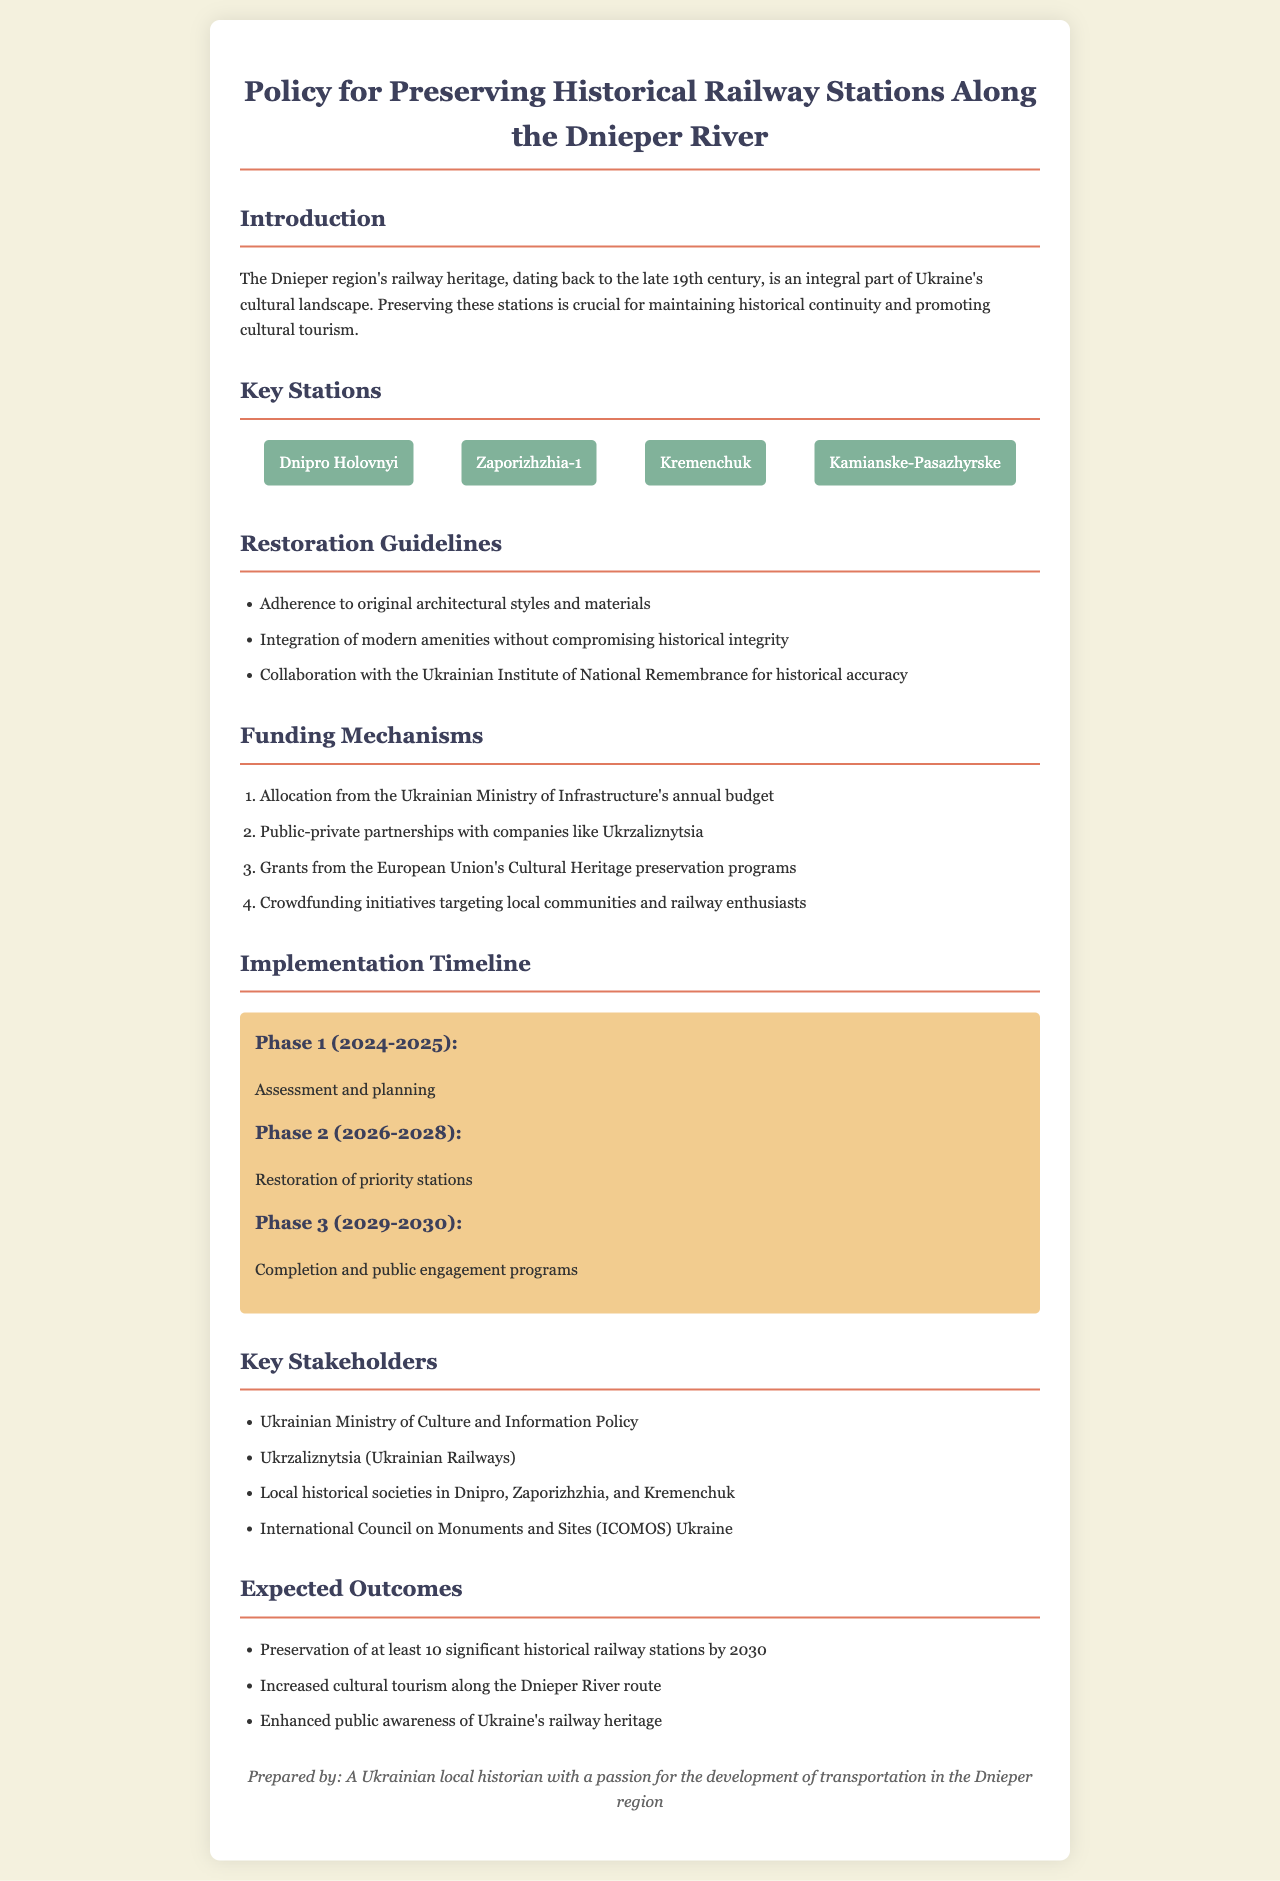What is the title of the policy document? The title of the policy document is specified in the header section of the document.
Answer: Policy for Preserving Historical Railway Stations Along the Dnieper River How many key stations are listed? The number of key stations can be counted from the "Key Stations" section of the document.
Answer: 4 What is the first phase of the implementation timeline? The first phase is described in the "Implementation Timeline" section, detailing the activities for that period.
Answer: Assessment and planning Which ministry allocates funding for the restoration? The relevant ministry responsible for funding is mentioned in the "Funding Mechanisms" section of the document.
Answer: Ukrainian Ministry of Infrastructure What is the expected number of preserved historical railway stations by 2030? The expected outcome regarding preservation is explicitly stated in the "Expected Outcomes" section.
Answer: 10 What type of partnerships are mentioned for funding restoration? The partnerships for funding are listed under the "Funding Mechanisms" section of the document, highlighting collaboration types.
Answer: Public-private partnerships Who is involved in ensuring historical accuracy during restoration? The organization responsible for ensuring historical accuracy is specified in the "Restoration Guidelines" section of the document.
Answer: Ukrainian Institute of National Remembrance In which years is Phase 2 scheduled to take place? The years for Phase 2 are indicated in the "Implementation Timeline" section of the document.
Answer: 2026-2028 